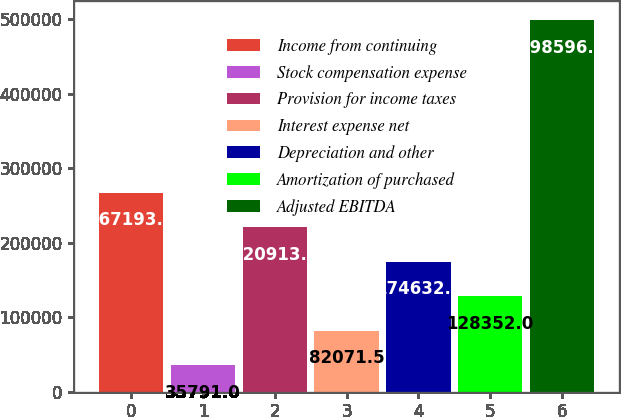Convert chart. <chart><loc_0><loc_0><loc_500><loc_500><bar_chart><fcel>Income from continuing<fcel>Stock compensation expense<fcel>Provision for income taxes<fcel>Interest expense net<fcel>Depreciation and other<fcel>Amortization of purchased<fcel>Adjusted EBITDA<nl><fcel>267194<fcel>35791<fcel>220913<fcel>82071.5<fcel>174632<fcel>128352<fcel>498596<nl></chart> 